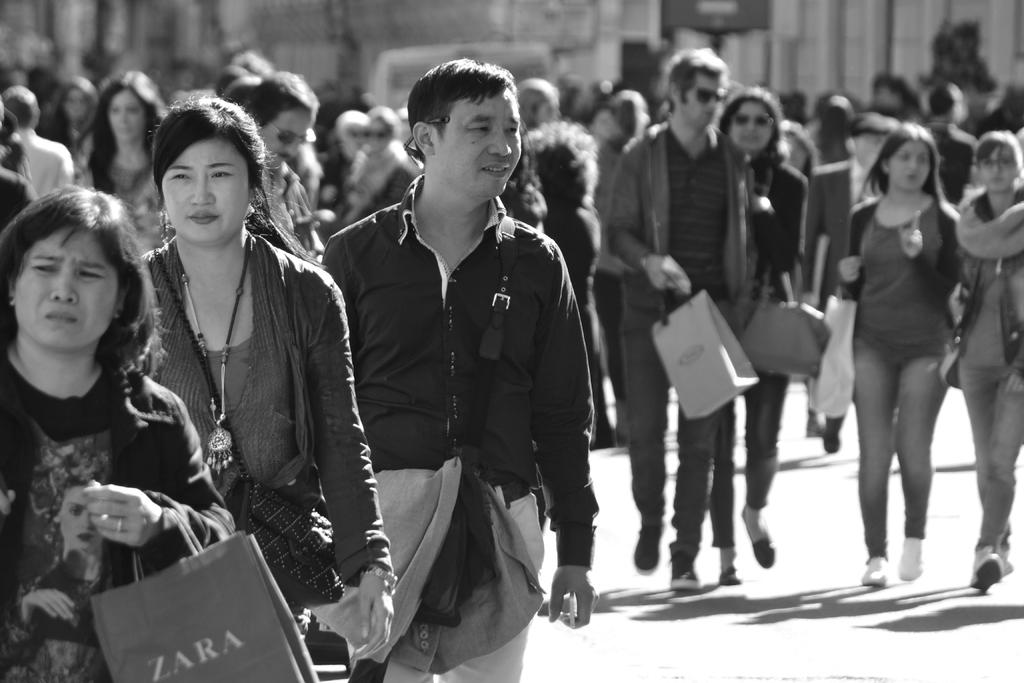What is happening with the group of people in the image? There is a group of people on the ground in the image. What are some of the people in the group doing? Some people in the group are carrying bags. What can be seen in the background of the image? There are objects visible in the background of the image, although they are blurry. How many thumbs can be seen in the image? There is no specific mention of thumbs in the image, so it is impossible to determine the number of thumbs present. 